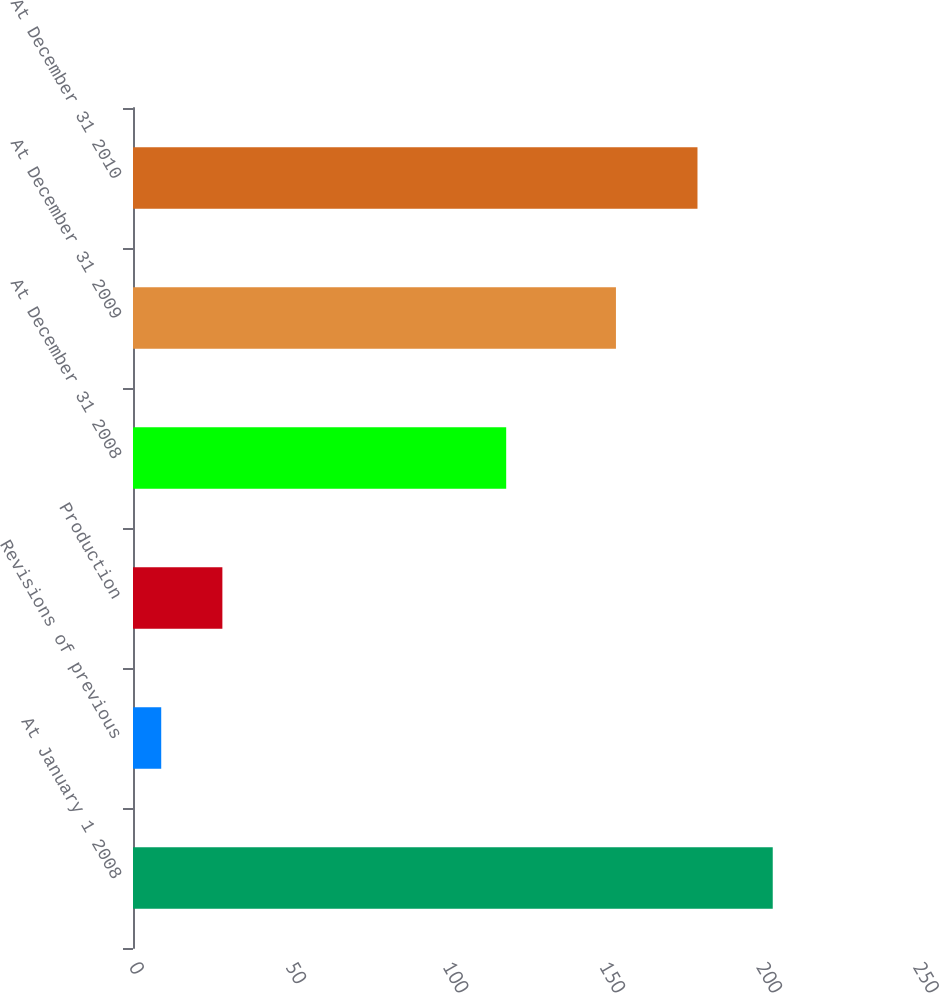<chart> <loc_0><loc_0><loc_500><loc_500><bar_chart><fcel>At January 1 2008<fcel>Revisions of previous<fcel>Production<fcel>At December 31 2008<fcel>At December 31 2009<fcel>At December 31 2010<nl><fcel>204<fcel>9<fcel>28.5<fcel>119<fcel>154<fcel>180<nl></chart> 